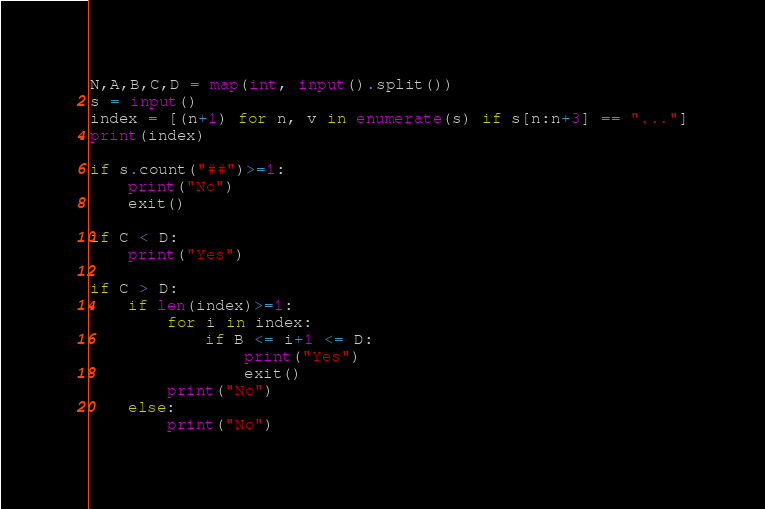<code> <loc_0><loc_0><loc_500><loc_500><_Python_>N,A,B,C,D = map(int, input().split())
s = input()
index = [(n+1) for n, v in enumerate(s) if s[n:n+3] == "..."]
print(index)

if s.count("##")>=1:
    print("No")
    exit()

if C < D:
    print("Yes")

if C > D:
    if len(index)>=1:
        for i in index:
            if B <= i+1 <= D:
                print("Yes")
                exit()
        print("No")
    else:
        print("No")
</code> 